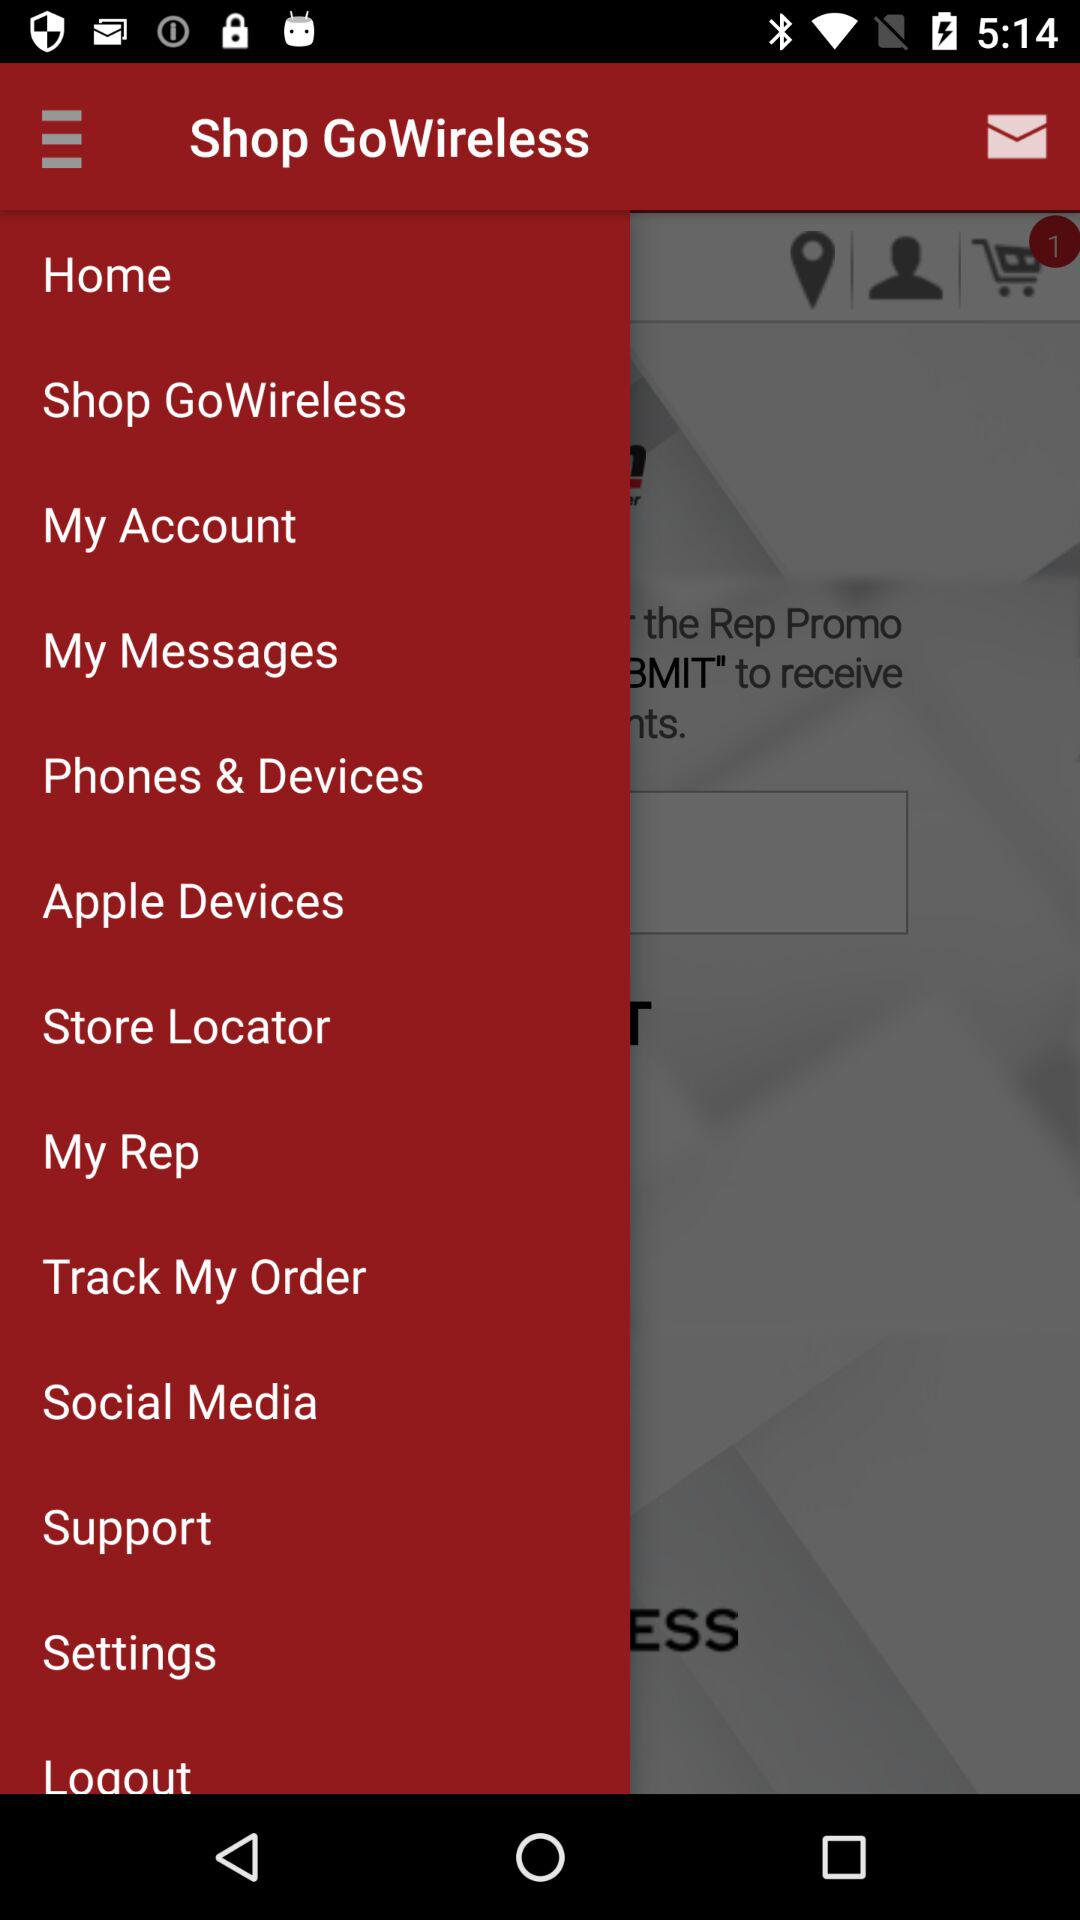Which Apple devices does the user have?
When the provided information is insufficient, respond with <no answer>. <no answer> 